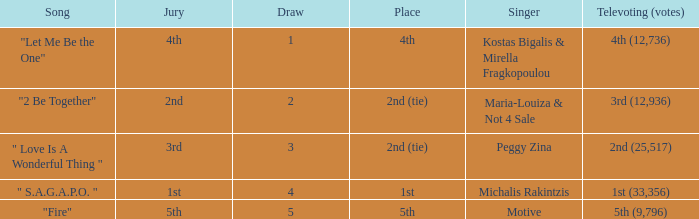Kostas Bigalis & Mirella Fragkopoulou the singer had what has the jury? 4th. 